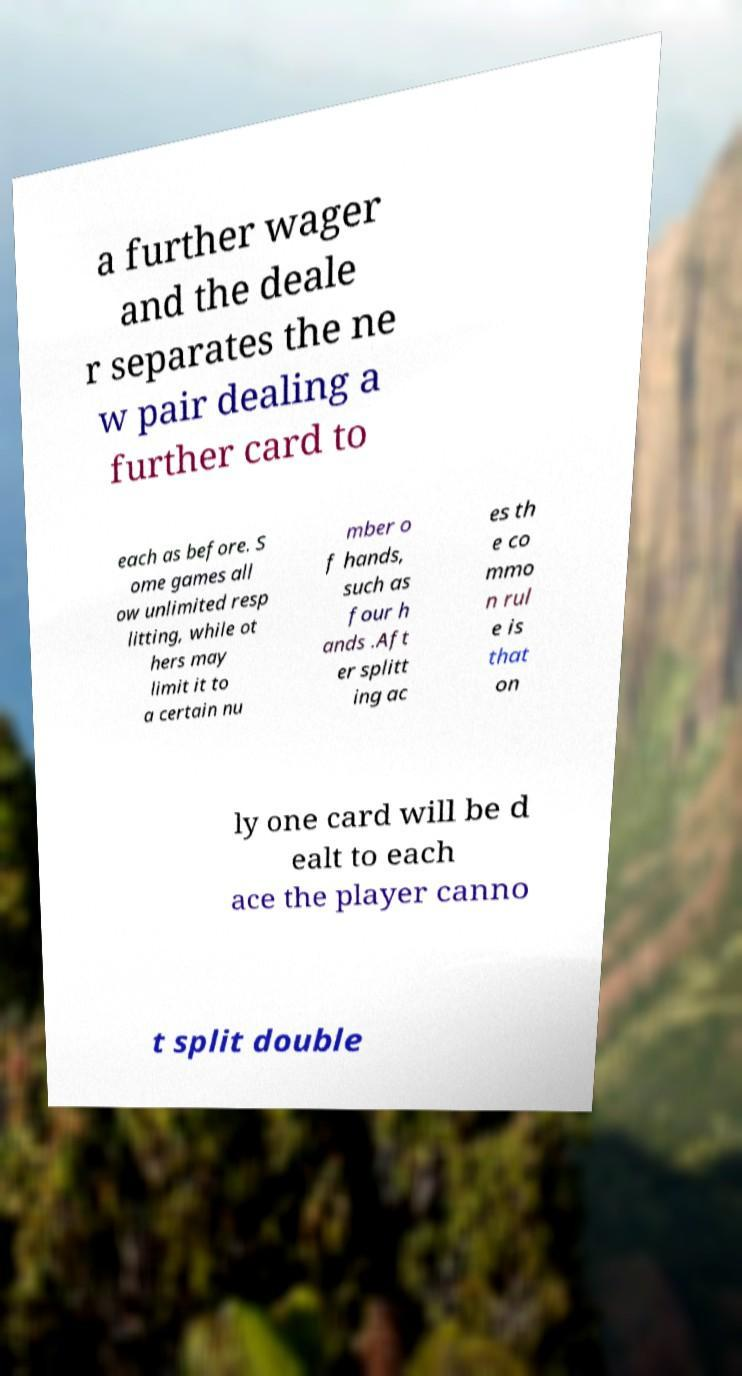Please read and relay the text visible in this image. What does it say? a further wager and the deale r separates the ne w pair dealing a further card to each as before. S ome games all ow unlimited resp litting, while ot hers may limit it to a certain nu mber o f hands, such as four h ands .Aft er splitt ing ac es th e co mmo n rul e is that on ly one card will be d ealt to each ace the player canno t split double 